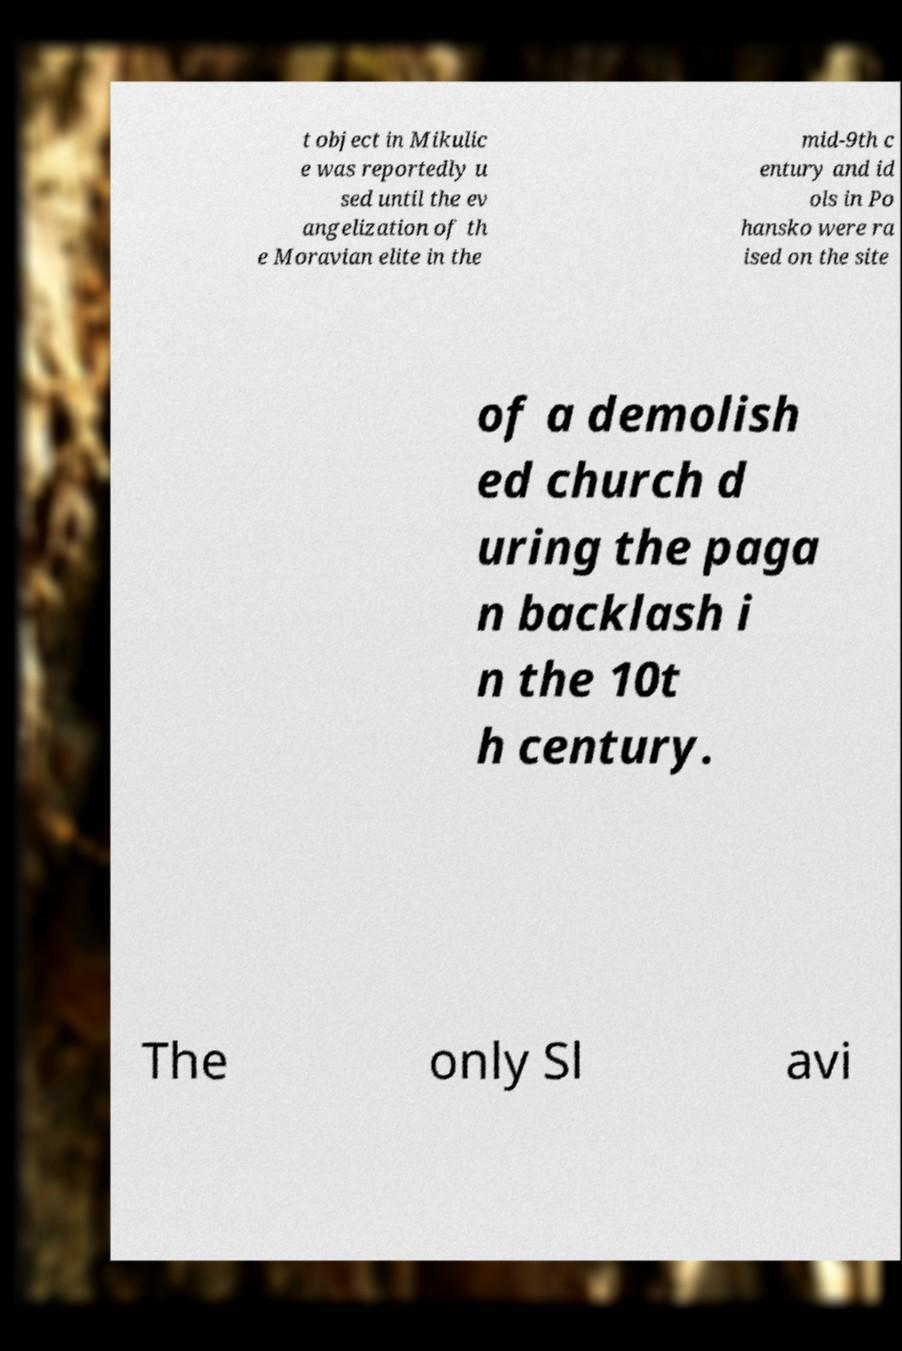Could you assist in decoding the text presented in this image and type it out clearly? t object in Mikulic e was reportedly u sed until the ev angelization of th e Moravian elite in the mid-9th c entury and id ols in Po hansko were ra ised on the site of a demolish ed church d uring the paga n backlash i n the 10t h century. The only Sl avi 